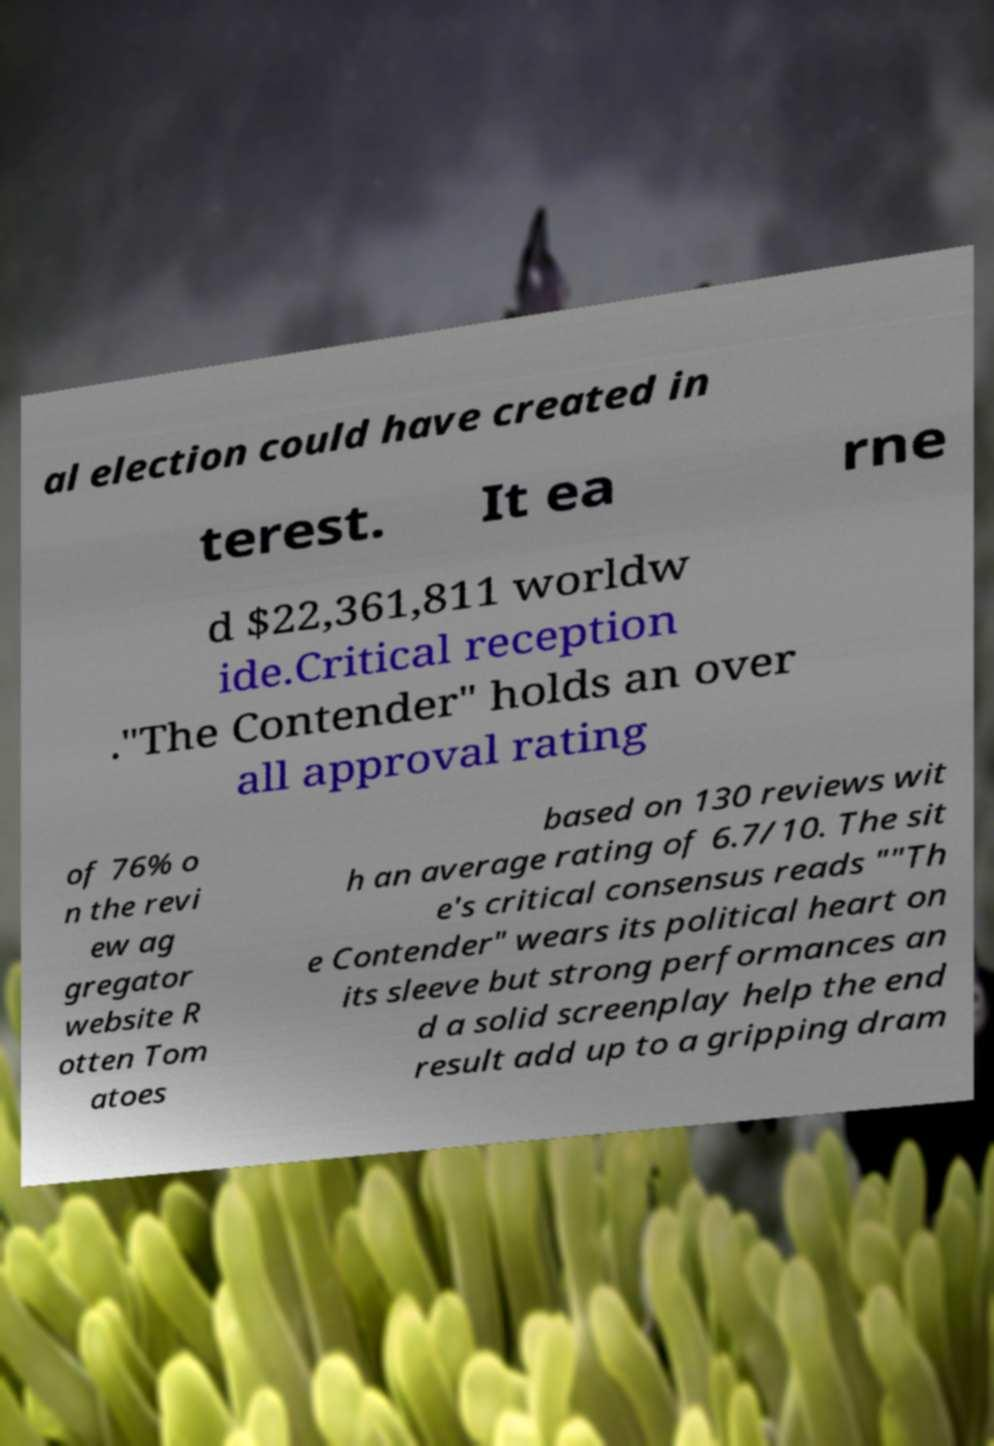For documentation purposes, I need the text within this image transcribed. Could you provide that? al election could have created in terest. It ea rne d $22,361,811 worldw ide.Critical reception ."The Contender" holds an over all approval rating of 76% o n the revi ew ag gregator website R otten Tom atoes based on 130 reviews wit h an average rating of 6.7/10. The sit e's critical consensus reads ""Th e Contender" wears its political heart on its sleeve but strong performances an d a solid screenplay help the end result add up to a gripping dram 